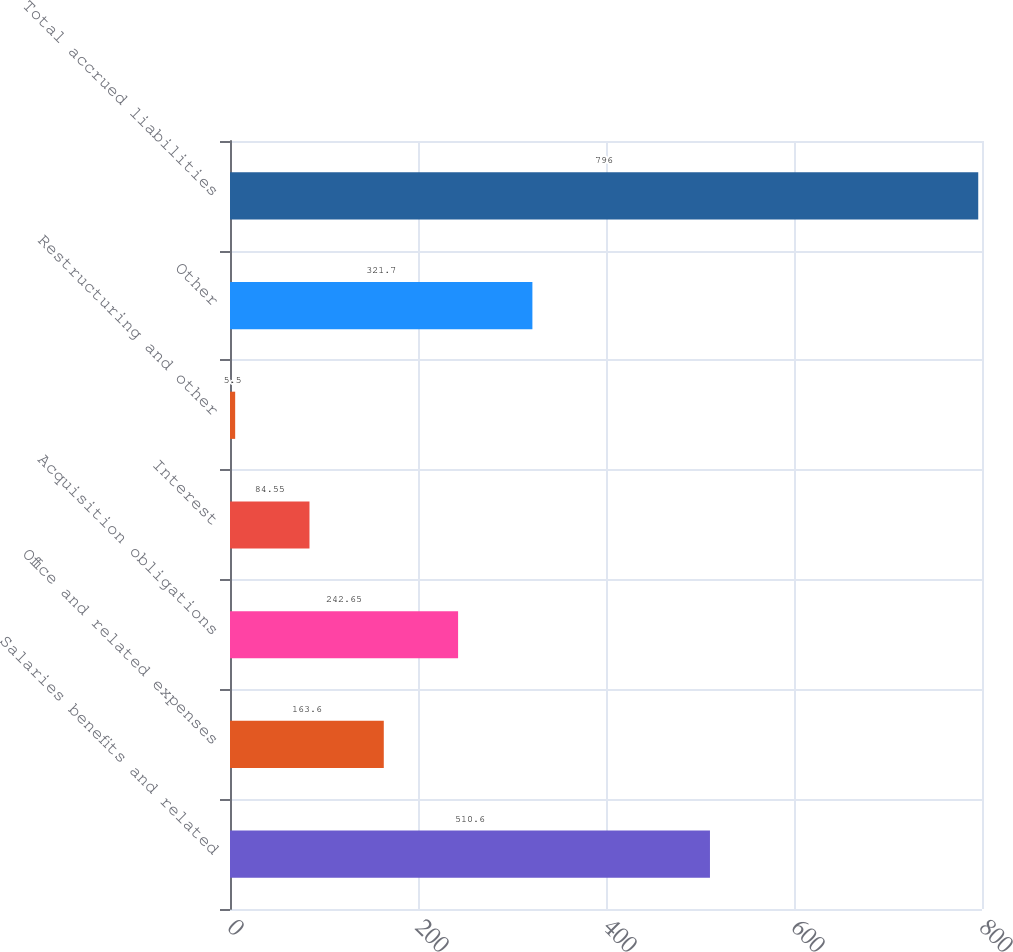Convert chart to OTSL. <chart><loc_0><loc_0><loc_500><loc_500><bar_chart><fcel>Salaries benefits and related<fcel>Office and related expenses<fcel>Acquisition obligations<fcel>Interest<fcel>Restructuring and other<fcel>Other<fcel>Total accrued liabilities<nl><fcel>510.6<fcel>163.6<fcel>242.65<fcel>84.55<fcel>5.5<fcel>321.7<fcel>796<nl></chart> 